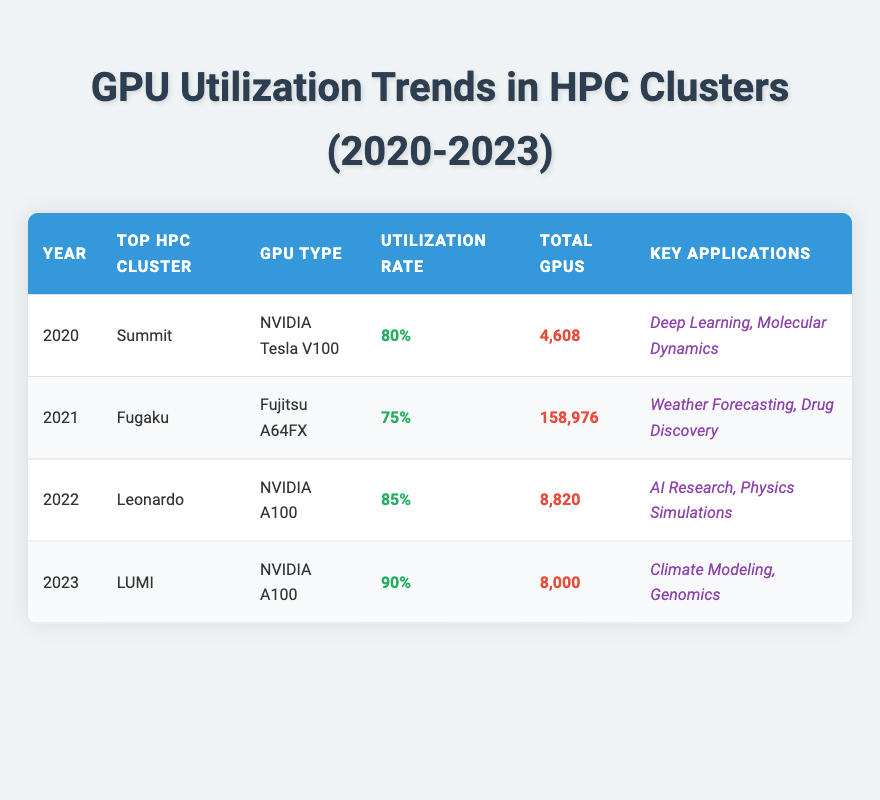What was the GPU utilization rate in 2021? In the table, the utilization rate for the year 2021 is specified directly in the row for the "Fugaku" cluster. It shows a utilization rate of 75%.
Answer: 75% What is the total number of GPUs in the top HPC cluster for 2022? The top HPC cluster for 2022 is "Leonardo," which has a total of 8,820 GPUs listed in the corresponding row of the table.
Answer: 8,820 Which year had the highest GPU utilization rate? By comparing the utilization rates across all years listed in the table: 80% (2020), 75% (2021), 85% (2022), and 90% (2023), it is clear that 2023 had the highest utilization rate of 90%.
Answer: 2023 What is the average GPU utilization rate from 2020 to 2023? The utilization rates for the years are 80%, 75%, 85%, and 90%. To find the average, sum these rates (80 + 75 + 85 + 90 = 330) and divide by the number of years (330 / 4 = 82.5). Therefore, the average utilization rate is 82.5%.
Answer: 82.5% Is it true that the total number of GPUs decreased from 2021 to 2022? In 2021, the total number of GPUs was 158,976 (Fugaku), and in 2022 it decreased to 8,820 (Leonardo), which confirms that the total number of GPUs did decrease over that period.
Answer: Yes Which key applications were predominantly utilized by the top HPC cluster in 2023? The "LUMI" cluster in 2023 has key applications listed as "Climate Modeling" and "Genomics." These applications can be found in the row for the year 2023 in the table.
Answer: Climate Modeling, Genomics How much did the total number of GPUs change from 2020 to 2023? The total number of GPUs in 2020 was 4,608, and in 2023, it is 8,000. To find the change, subtract the earlier total from the later total (8,000 - 4,608 = 3,392). Thus, the total number of GPUs increased by 3,392 from 2020 to 2023.
Answer: Increased by 3,392 Did any of the top HPC clusters use the same type of GPU in consecutive years? Looking at the table: "NVIDIA A100" was used in both 2022 (Leonardo) and 2023 (LUMI), confirming that the same type of GPU was utilized in consecutive years.
Answer: Yes In which year did the top HPC cluster first have a utilization rate of 85% or higher? By examining the utilization rates, the row for 2022 shows a utilization rate of 85%. Since this is the first instance in the table above 85%, it indicates that the first occurrence of a utilization rate of 85% or higher was in 2022.
Answer: 2022 